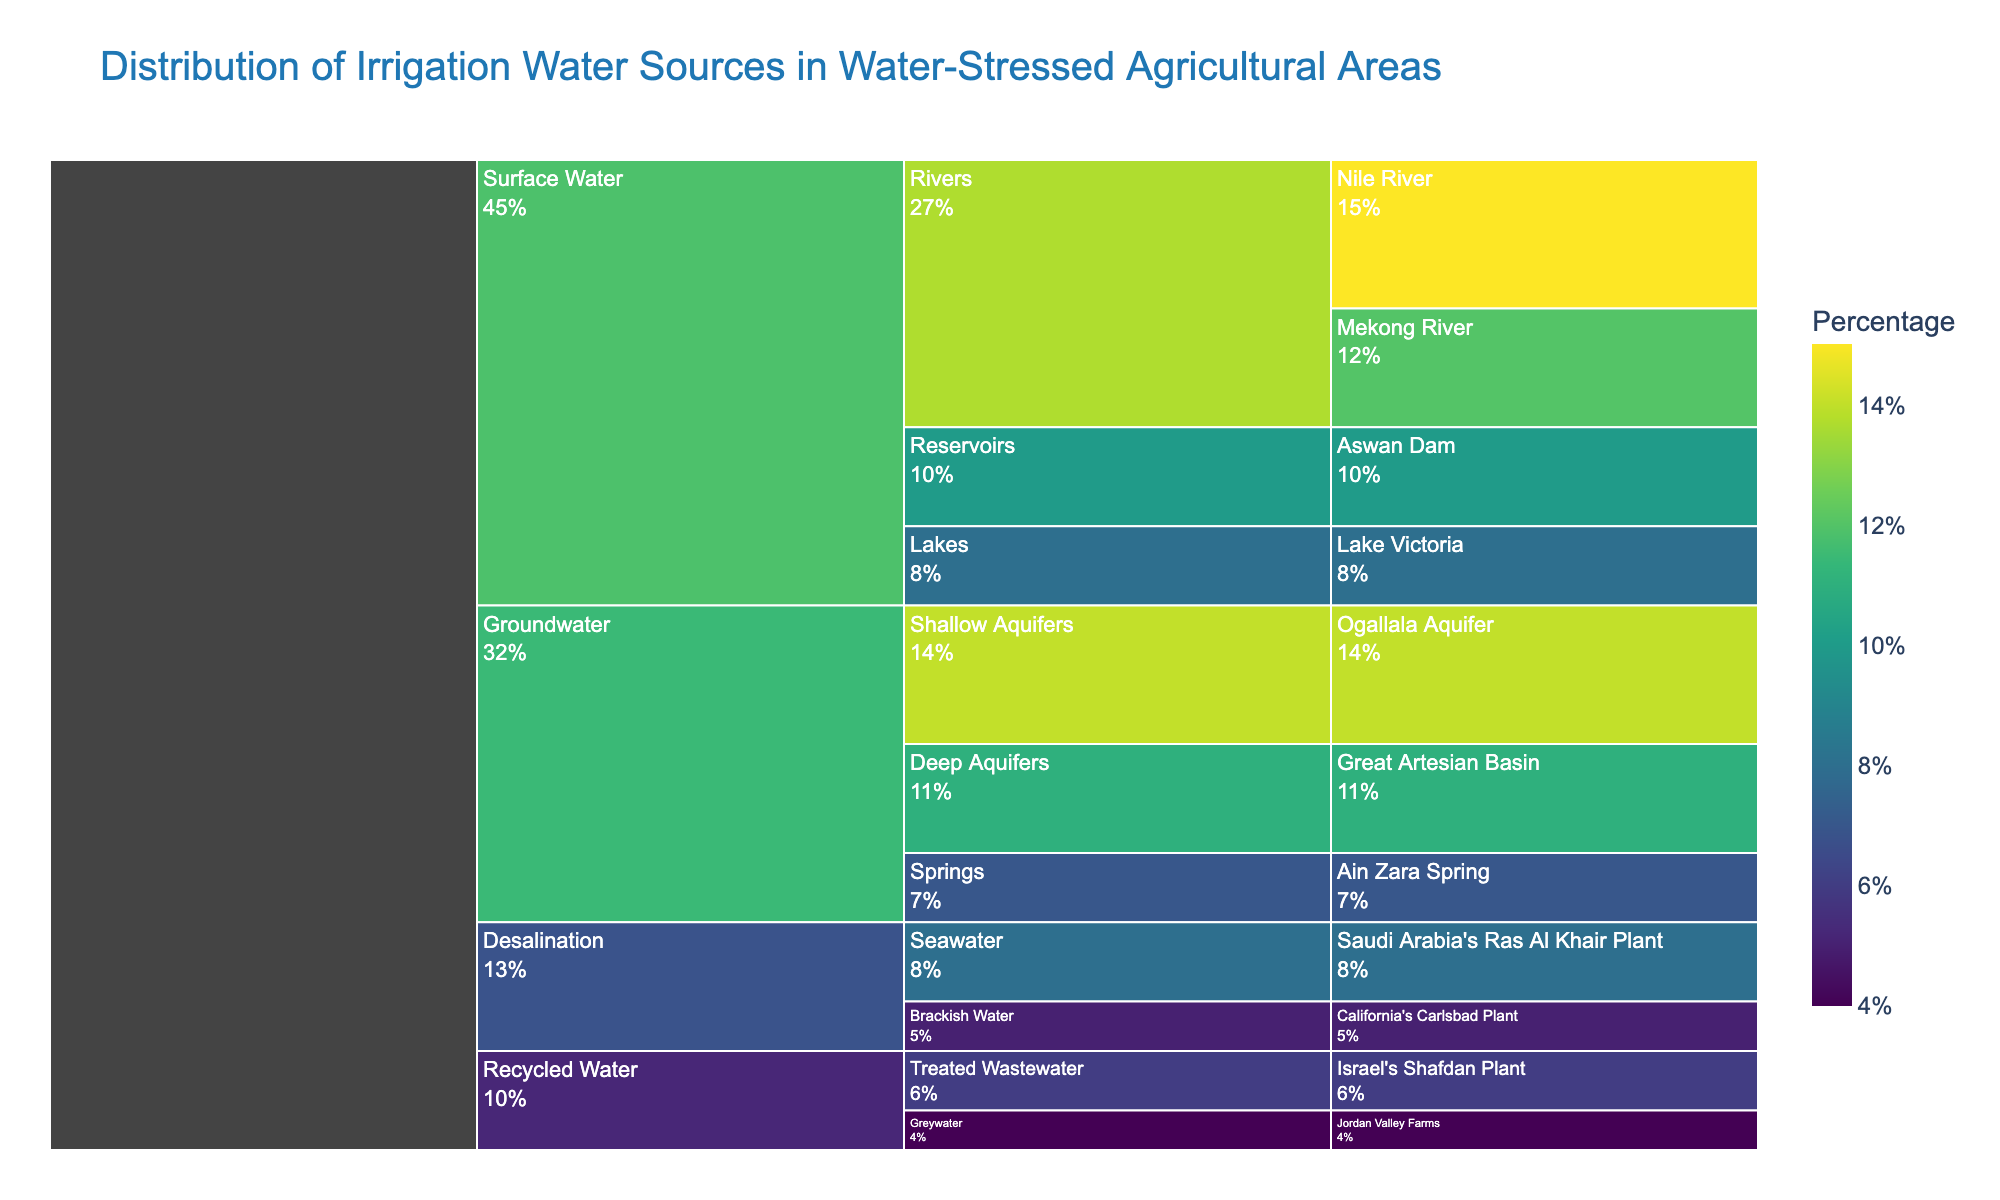What is the title of the icicle chart? The title of the chart is displayed at the top and provides the main insight or topic that the chart covers. In this case, it's "Distribution of Irrigation Water Sources in Water-Stressed Agricultural Areas".
Answer: Distribution of Irrigation Water Sources in Water-Stressed Agricultural Areas How much percentage of the irrigation water comes from the Nile River? Locate the section labeled "Nile River" under the "Rivers" subcategory in the "Surface Water" category; the percentage is shown in the same section.
Answer: 15% Which source has the lowest percentage of irrigation water and what is it? Identify the source with the smallest area in the icicle chart and check the label for its percentage. "Greywater" has the smallest section.
Answer: Greywater, 4% What is the total percentage of irrigation water contributed by Groundwater sources? Sum up the percentages of all three sources under the Groundwater category (Shallow Aquifers, Deep Aquifers, Springs): 14% + 11% + 7%.
Answer: 32% Compare the total percentage of irrigation water from Surface Water and Desalination sources. Which one is higher, and by how much? Calculate the total percentage for Surface Water (Rivers: 15% + 12%, Lakes: 8%, Reservoirs: 10%) and Desalination (Seawater: 8%, Brackish Water: 5%). Then determine the difference: (15 + 12 + 8 + 10) - (8 + 5).
Answer: Surface Water is higher by 32% Which subcategory within Surface Water contributes the most to irrigation water and what is the percentage? Under the Surface Water category, compare the percentages of Rivers, Lakes, and Reservoirs. Rivers have the highest sum (Nile River: 15% + Mekong River: 12%).
Answer: Rivers, 27% How does the percentage from Israel’s Shafdan Plant compare to the percentage from California's Carlsbad Plant? Check the percentages for both Israel's Shafdan Plant under Recycled Water and California's Carlsbad Plant under Desalination. Compare 6% and 5%.
Answer: Israel’s Shafdan Plant is 1% higher What source contributes exactly 10% to the total irrigation water? Locate the section that shows a 10% contribution and check the label; the Aswan Dam under Reservoirs shows 10%.
Answer: Aswan Dam What is the combined percentage contribution of all Surface Water sources? Add together the percentages of all sources under Surface Water (Nile River: 15%, Mekong River: 12%, Lake Victoria: 8%, Aswan Dam: 10%).
Answer: 45% Which has a higher percentage contribution to irrigation water: Recycled Water or Desalination? Calculate the total percentage for Recycled Water (Treated Wastewater: 6%, Greywater: 4%) and for Desalination (Seawater: 8%, Brackish Water: 5%). Compare 10% and 13%.
Answer: Desalination is higher by 3% 